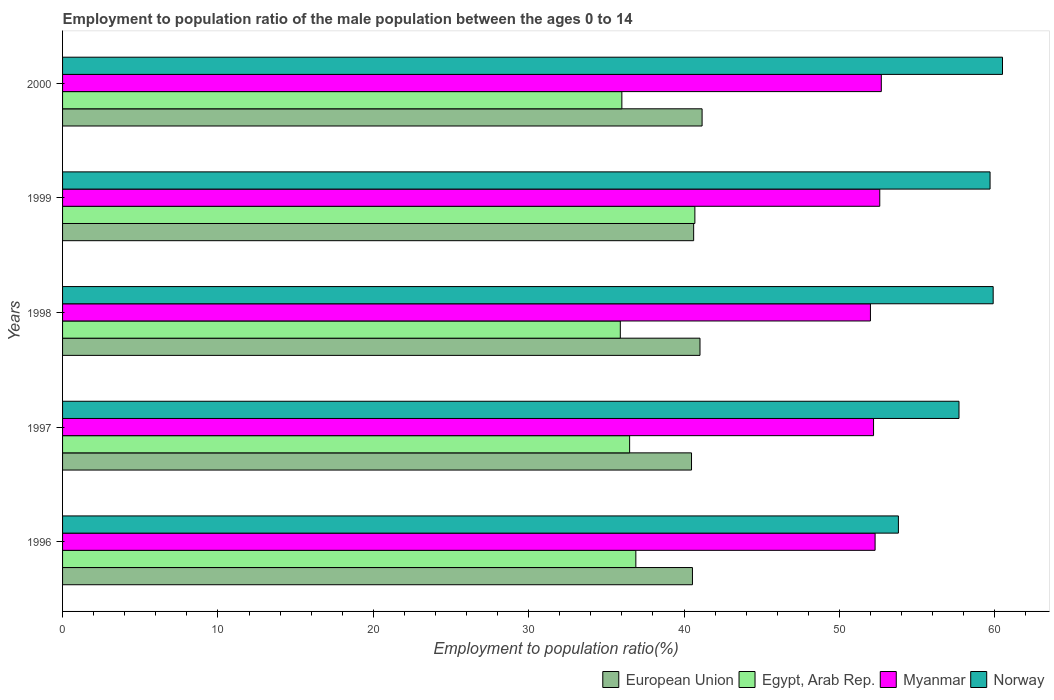How many different coloured bars are there?
Your answer should be compact. 4. Are the number of bars per tick equal to the number of legend labels?
Give a very brief answer. Yes. Are the number of bars on each tick of the Y-axis equal?
Keep it short and to the point. Yes. How many bars are there on the 4th tick from the top?
Ensure brevity in your answer.  4. What is the label of the 5th group of bars from the top?
Provide a succinct answer. 1996. What is the employment to population ratio in Norway in 1996?
Provide a succinct answer. 53.8. Across all years, what is the maximum employment to population ratio in Egypt, Arab Rep.?
Keep it short and to the point. 40.7. Across all years, what is the minimum employment to population ratio in Norway?
Your answer should be compact. 53.8. In which year was the employment to population ratio in European Union minimum?
Provide a succinct answer. 1997. What is the total employment to population ratio in European Union in the graph?
Your answer should be compact. 203.84. What is the difference between the employment to population ratio in European Union in 1996 and that in 1998?
Offer a very short reply. -0.49. What is the difference between the employment to population ratio in Egypt, Arab Rep. in 2000 and the employment to population ratio in Myanmar in 1998?
Your response must be concise. -16. What is the average employment to population ratio in European Union per year?
Offer a very short reply. 40.77. In the year 1997, what is the difference between the employment to population ratio in European Union and employment to population ratio in Norway?
Make the answer very short. -17.22. In how many years, is the employment to population ratio in Egypt, Arab Rep. greater than 30 %?
Give a very brief answer. 5. What is the ratio of the employment to population ratio in Egypt, Arab Rep. in 1996 to that in 2000?
Your answer should be compact. 1.03. What is the difference between the highest and the second highest employment to population ratio in European Union?
Keep it short and to the point. 0.13. What is the difference between the highest and the lowest employment to population ratio in Norway?
Your answer should be very brief. 6.7. In how many years, is the employment to population ratio in Myanmar greater than the average employment to population ratio in Myanmar taken over all years?
Your answer should be very brief. 2. Is the sum of the employment to population ratio in European Union in 1996 and 1997 greater than the maximum employment to population ratio in Myanmar across all years?
Your answer should be very brief. Yes. Is it the case that in every year, the sum of the employment to population ratio in Myanmar and employment to population ratio in Norway is greater than the employment to population ratio in Egypt, Arab Rep.?
Your answer should be compact. Yes. How many bars are there?
Make the answer very short. 20. Does the graph contain grids?
Ensure brevity in your answer.  No. Where does the legend appear in the graph?
Keep it short and to the point. Bottom right. How many legend labels are there?
Your answer should be very brief. 4. How are the legend labels stacked?
Provide a succinct answer. Horizontal. What is the title of the graph?
Your response must be concise. Employment to population ratio of the male population between the ages 0 to 14. What is the label or title of the Y-axis?
Keep it short and to the point. Years. What is the Employment to population ratio(%) of European Union in 1996?
Give a very brief answer. 40.54. What is the Employment to population ratio(%) of Egypt, Arab Rep. in 1996?
Ensure brevity in your answer.  36.9. What is the Employment to population ratio(%) of Myanmar in 1996?
Ensure brevity in your answer.  52.3. What is the Employment to population ratio(%) of Norway in 1996?
Your answer should be compact. 53.8. What is the Employment to population ratio(%) in European Union in 1997?
Your answer should be very brief. 40.48. What is the Employment to population ratio(%) in Egypt, Arab Rep. in 1997?
Offer a very short reply. 36.5. What is the Employment to population ratio(%) in Myanmar in 1997?
Your response must be concise. 52.2. What is the Employment to population ratio(%) of Norway in 1997?
Ensure brevity in your answer.  57.7. What is the Employment to population ratio(%) in European Union in 1998?
Your answer should be very brief. 41.03. What is the Employment to population ratio(%) in Egypt, Arab Rep. in 1998?
Ensure brevity in your answer.  35.9. What is the Employment to population ratio(%) of Myanmar in 1998?
Offer a terse response. 52. What is the Employment to population ratio(%) in Norway in 1998?
Your response must be concise. 59.9. What is the Employment to population ratio(%) of European Union in 1999?
Your response must be concise. 40.62. What is the Employment to population ratio(%) of Egypt, Arab Rep. in 1999?
Provide a short and direct response. 40.7. What is the Employment to population ratio(%) of Myanmar in 1999?
Provide a succinct answer. 52.6. What is the Employment to population ratio(%) of Norway in 1999?
Offer a very short reply. 59.7. What is the Employment to population ratio(%) of European Union in 2000?
Make the answer very short. 41.16. What is the Employment to population ratio(%) of Myanmar in 2000?
Make the answer very short. 52.7. What is the Employment to population ratio(%) in Norway in 2000?
Make the answer very short. 60.5. Across all years, what is the maximum Employment to population ratio(%) in European Union?
Make the answer very short. 41.16. Across all years, what is the maximum Employment to population ratio(%) in Egypt, Arab Rep.?
Provide a succinct answer. 40.7. Across all years, what is the maximum Employment to population ratio(%) in Myanmar?
Your response must be concise. 52.7. Across all years, what is the maximum Employment to population ratio(%) in Norway?
Ensure brevity in your answer.  60.5. Across all years, what is the minimum Employment to population ratio(%) of European Union?
Ensure brevity in your answer.  40.48. Across all years, what is the minimum Employment to population ratio(%) of Egypt, Arab Rep.?
Give a very brief answer. 35.9. Across all years, what is the minimum Employment to population ratio(%) in Norway?
Ensure brevity in your answer.  53.8. What is the total Employment to population ratio(%) of European Union in the graph?
Ensure brevity in your answer.  203.84. What is the total Employment to population ratio(%) in Egypt, Arab Rep. in the graph?
Make the answer very short. 186. What is the total Employment to population ratio(%) of Myanmar in the graph?
Ensure brevity in your answer.  261.8. What is the total Employment to population ratio(%) of Norway in the graph?
Your answer should be very brief. 291.6. What is the difference between the Employment to population ratio(%) of European Union in 1996 and that in 1997?
Keep it short and to the point. 0.06. What is the difference between the Employment to population ratio(%) in Myanmar in 1996 and that in 1997?
Offer a terse response. 0.1. What is the difference between the Employment to population ratio(%) in Norway in 1996 and that in 1997?
Offer a terse response. -3.9. What is the difference between the Employment to population ratio(%) in European Union in 1996 and that in 1998?
Give a very brief answer. -0.49. What is the difference between the Employment to population ratio(%) of Myanmar in 1996 and that in 1998?
Offer a terse response. 0.3. What is the difference between the Employment to population ratio(%) of European Union in 1996 and that in 1999?
Provide a short and direct response. -0.08. What is the difference between the Employment to population ratio(%) of Egypt, Arab Rep. in 1996 and that in 1999?
Ensure brevity in your answer.  -3.8. What is the difference between the Employment to population ratio(%) in Norway in 1996 and that in 1999?
Offer a very short reply. -5.9. What is the difference between the Employment to population ratio(%) of European Union in 1996 and that in 2000?
Ensure brevity in your answer.  -0.62. What is the difference between the Employment to population ratio(%) in Norway in 1996 and that in 2000?
Ensure brevity in your answer.  -6.7. What is the difference between the Employment to population ratio(%) in European Union in 1997 and that in 1998?
Ensure brevity in your answer.  -0.55. What is the difference between the Employment to population ratio(%) of European Union in 1997 and that in 1999?
Provide a short and direct response. -0.14. What is the difference between the Employment to population ratio(%) of Egypt, Arab Rep. in 1997 and that in 1999?
Keep it short and to the point. -4.2. What is the difference between the Employment to population ratio(%) in Myanmar in 1997 and that in 1999?
Offer a terse response. -0.4. What is the difference between the Employment to population ratio(%) of Norway in 1997 and that in 1999?
Provide a short and direct response. -2. What is the difference between the Employment to population ratio(%) of European Union in 1997 and that in 2000?
Offer a very short reply. -0.68. What is the difference between the Employment to population ratio(%) of Egypt, Arab Rep. in 1997 and that in 2000?
Provide a succinct answer. 0.5. What is the difference between the Employment to population ratio(%) of Myanmar in 1997 and that in 2000?
Keep it short and to the point. -0.5. What is the difference between the Employment to population ratio(%) of European Union in 1998 and that in 1999?
Your response must be concise. 0.41. What is the difference between the Employment to population ratio(%) in Myanmar in 1998 and that in 1999?
Offer a terse response. -0.6. What is the difference between the Employment to population ratio(%) in Norway in 1998 and that in 1999?
Offer a very short reply. 0.2. What is the difference between the Employment to population ratio(%) in European Union in 1998 and that in 2000?
Make the answer very short. -0.13. What is the difference between the Employment to population ratio(%) of Egypt, Arab Rep. in 1998 and that in 2000?
Ensure brevity in your answer.  -0.1. What is the difference between the Employment to population ratio(%) in European Union in 1999 and that in 2000?
Provide a short and direct response. -0.54. What is the difference between the Employment to population ratio(%) in European Union in 1996 and the Employment to population ratio(%) in Egypt, Arab Rep. in 1997?
Provide a short and direct response. 4.04. What is the difference between the Employment to population ratio(%) in European Union in 1996 and the Employment to population ratio(%) in Myanmar in 1997?
Provide a succinct answer. -11.66. What is the difference between the Employment to population ratio(%) in European Union in 1996 and the Employment to population ratio(%) in Norway in 1997?
Your response must be concise. -17.16. What is the difference between the Employment to population ratio(%) in Egypt, Arab Rep. in 1996 and the Employment to population ratio(%) in Myanmar in 1997?
Your answer should be compact. -15.3. What is the difference between the Employment to population ratio(%) in Egypt, Arab Rep. in 1996 and the Employment to population ratio(%) in Norway in 1997?
Offer a very short reply. -20.8. What is the difference between the Employment to population ratio(%) in European Union in 1996 and the Employment to population ratio(%) in Egypt, Arab Rep. in 1998?
Your answer should be very brief. 4.64. What is the difference between the Employment to population ratio(%) in European Union in 1996 and the Employment to population ratio(%) in Myanmar in 1998?
Keep it short and to the point. -11.46. What is the difference between the Employment to population ratio(%) in European Union in 1996 and the Employment to population ratio(%) in Norway in 1998?
Keep it short and to the point. -19.36. What is the difference between the Employment to population ratio(%) in Egypt, Arab Rep. in 1996 and the Employment to population ratio(%) in Myanmar in 1998?
Offer a terse response. -15.1. What is the difference between the Employment to population ratio(%) of Egypt, Arab Rep. in 1996 and the Employment to population ratio(%) of Norway in 1998?
Your answer should be very brief. -23. What is the difference between the Employment to population ratio(%) in European Union in 1996 and the Employment to population ratio(%) in Egypt, Arab Rep. in 1999?
Offer a very short reply. -0.16. What is the difference between the Employment to population ratio(%) in European Union in 1996 and the Employment to population ratio(%) in Myanmar in 1999?
Ensure brevity in your answer.  -12.06. What is the difference between the Employment to population ratio(%) of European Union in 1996 and the Employment to population ratio(%) of Norway in 1999?
Your response must be concise. -19.16. What is the difference between the Employment to population ratio(%) of Egypt, Arab Rep. in 1996 and the Employment to population ratio(%) of Myanmar in 1999?
Make the answer very short. -15.7. What is the difference between the Employment to population ratio(%) in Egypt, Arab Rep. in 1996 and the Employment to population ratio(%) in Norway in 1999?
Make the answer very short. -22.8. What is the difference between the Employment to population ratio(%) of European Union in 1996 and the Employment to population ratio(%) of Egypt, Arab Rep. in 2000?
Offer a very short reply. 4.54. What is the difference between the Employment to population ratio(%) in European Union in 1996 and the Employment to population ratio(%) in Myanmar in 2000?
Make the answer very short. -12.16. What is the difference between the Employment to population ratio(%) of European Union in 1996 and the Employment to population ratio(%) of Norway in 2000?
Provide a short and direct response. -19.96. What is the difference between the Employment to population ratio(%) in Egypt, Arab Rep. in 1996 and the Employment to population ratio(%) in Myanmar in 2000?
Make the answer very short. -15.8. What is the difference between the Employment to population ratio(%) of Egypt, Arab Rep. in 1996 and the Employment to population ratio(%) of Norway in 2000?
Provide a succinct answer. -23.6. What is the difference between the Employment to population ratio(%) of European Union in 1997 and the Employment to population ratio(%) of Egypt, Arab Rep. in 1998?
Your answer should be compact. 4.58. What is the difference between the Employment to population ratio(%) in European Union in 1997 and the Employment to population ratio(%) in Myanmar in 1998?
Provide a short and direct response. -11.52. What is the difference between the Employment to population ratio(%) of European Union in 1997 and the Employment to population ratio(%) of Norway in 1998?
Provide a succinct answer. -19.42. What is the difference between the Employment to population ratio(%) in Egypt, Arab Rep. in 1997 and the Employment to population ratio(%) in Myanmar in 1998?
Keep it short and to the point. -15.5. What is the difference between the Employment to population ratio(%) in Egypt, Arab Rep. in 1997 and the Employment to population ratio(%) in Norway in 1998?
Make the answer very short. -23.4. What is the difference between the Employment to population ratio(%) of European Union in 1997 and the Employment to population ratio(%) of Egypt, Arab Rep. in 1999?
Offer a terse response. -0.22. What is the difference between the Employment to population ratio(%) in European Union in 1997 and the Employment to population ratio(%) in Myanmar in 1999?
Ensure brevity in your answer.  -12.12. What is the difference between the Employment to population ratio(%) of European Union in 1997 and the Employment to population ratio(%) of Norway in 1999?
Your answer should be compact. -19.22. What is the difference between the Employment to population ratio(%) of Egypt, Arab Rep. in 1997 and the Employment to population ratio(%) of Myanmar in 1999?
Make the answer very short. -16.1. What is the difference between the Employment to population ratio(%) in Egypt, Arab Rep. in 1997 and the Employment to population ratio(%) in Norway in 1999?
Provide a short and direct response. -23.2. What is the difference between the Employment to population ratio(%) of Myanmar in 1997 and the Employment to population ratio(%) of Norway in 1999?
Offer a very short reply. -7.5. What is the difference between the Employment to population ratio(%) of European Union in 1997 and the Employment to population ratio(%) of Egypt, Arab Rep. in 2000?
Your answer should be compact. 4.48. What is the difference between the Employment to population ratio(%) in European Union in 1997 and the Employment to population ratio(%) in Myanmar in 2000?
Your answer should be very brief. -12.22. What is the difference between the Employment to population ratio(%) of European Union in 1997 and the Employment to population ratio(%) of Norway in 2000?
Provide a short and direct response. -20.02. What is the difference between the Employment to population ratio(%) in Egypt, Arab Rep. in 1997 and the Employment to population ratio(%) in Myanmar in 2000?
Provide a short and direct response. -16.2. What is the difference between the Employment to population ratio(%) of European Union in 1998 and the Employment to population ratio(%) of Egypt, Arab Rep. in 1999?
Provide a short and direct response. 0.33. What is the difference between the Employment to population ratio(%) in European Union in 1998 and the Employment to population ratio(%) in Myanmar in 1999?
Your answer should be very brief. -11.57. What is the difference between the Employment to population ratio(%) of European Union in 1998 and the Employment to population ratio(%) of Norway in 1999?
Provide a short and direct response. -18.67. What is the difference between the Employment to population ratio(%) in Egypt, Arab Rep. in 1998 and the Employment to population ratio(%) in Myanmar in 1999?
Your response must be concise. -16.7. What is the difference between the Employment to population ratio(%) in Egypt, Arab Rep. in 1998 and the Employment to population ratio(%) in Norway in 1999?
Offer a very short reply. -23.8. What is the difference between the Employment to population ratio(%) of European Union in 1998 and the Employment to population ratio(%) of Egypt, Arab Rep. in 2000?
Your response must be concise. 5.03. What is the difference between the Employment to population ratio(%) in European Union in 1998 and the Employment to population ratio(%) in Myanmar in 2000?
Provide a short and direct response. -11.67. What is the difference between the Employment to population ratio(%) in European Union in 1998 and the Employment to population ratio(%) in Norway in 2000?
Make the answer very short. -19.47. What is the difference between the Employment to population ratio(%) of Egypt, Arab Rep. in 1998 and the Employment to population ratio(%) of Myanmar in 2000?
Ensure brevity in your answer.  -16.8. What is the difference between the Employment to population ratio(%) of Egypt, Arab Rep. in 1998 and the Employment to population ratio(%) of Norway in 2000?
Ensure brevity in your answer.  -24.6. What is the difference between the Employment to population ratio(%) of European Union in 1999 and the Employment to population ratio(%) of Egypt, Arab Rep. in 2000?
Provide a succinct answer. 4.62. What is the difference between the Employment to population ratio(%) of European Union in 1999 and the Employment to population ratio(%) of Myanmar in 2000?
Your response must be concise. -12.08. What is the difference between the Employment to population ratio(%) of European Union in 1999 and the Employment to population ratio(%) of Norway in 2000?
Offer a very short reply. -19.88. What is the difference between the Employment to population ratio(%) in Egypt, Arab Rep. in 1999 and the Employment to population ratio(%) in Myanmar in 2000?
Your answer should be compact. -12. What is the difference between the Employment to population ratio(%) of Egypt, Arab Rep. in 1999 and the Employment to population ratio(%) of Norway in 2000?
Keep it short and to the point. -19.8. What is the difference between the Employment to population ratio(%) in Myanmar in 1999 and the Employment to population ratio(%) in Norway in 2000?
Your answer should be very brief. -7.9. What is the average Employment to population ratio(%) in European Union per year?
Offer a very short reply. 40.77. What is the average Employment to population ratio(%) of Egypt, Arab Rep. per year?
Your response must be concise. 37.2. What is the average Employment to population ratio(%) in Myanmar per year?
Give a very brief answer. 52.36. What is the average Employment to population ratio(%) of Norway per year?
Offer a very short reply. 58.32. In the year 1996, what is the difference between the Employment to population ratio(%) of European Union and Employment to population ratio(%) of Egypt, Arab Rep.?
Make the answer very short. 3.64. In the year 1996, what is the difference between the Employment to population ratio(%) in European Union and Employment to population ratio(%) in Myanmar?
Keep it short and to the point. -11.76. In the year 1996, what is the difference between the Employment to population ratio(%) in European Union and Employment to population ratio(%) in Norway?
Provide a short and direct response. -13.26. In the year 1996, what is the difference between the Employment to population ratio(%) in Egypt, Arab Rep. and Employment to population ratio(%) in Myanmar?
Offer a terse response. -15.4. In the year 1996, what is the difference between the Employment to population ratio(%) in Egypt, Arab Rep. and Employment to population ratio(%) in Norway?
Provide a succinct answer. -16.9. In the year 1997, what is the difference between the Employment to population ratio(%) of European Union and Employment to population ratio(%) of Egypt, Arab Rep.?
Provide a succinct answer. 3.98. In the year 1997, what is the difference between the Employment to population ratio(%) of European Union and Employment to population ratio(%) of Myanmar?
Your answer should be very brief. -11.72. In the year 1997, what is the difference between the Employment to population ratio(%) in European Union and Employment to population ratio(%) in Norway?
Keep it short and to the point. -17.22. In the year 1997, what is the difference between the Employment to population ratio(%) of Egypt, Arab Rep. and Employment to population ratio(%) of Myanmar?
Keep it short and to the point. -15.7. In the year 1997, what is the difference between the Employment to population ratio(%) in Egypt, Arab Rep. and Employment to population ratio(%) in Norway?
Offer a very short reply. -21.2. In the year 1997, what is the difference between the Employment to population ratio(%) of Myanmar and Employment to population ratio(%) of Norway?
Your answer should be very brief. -5.5. In the year 1998, what is the difference between the Employment to population ratio(%) of European Union and Employment to population ratio(%) of Egypt, Arab Rep.?
Provide a succinct answer. 5.13. In the year 1998, what is the difference between the Employment to population ratio(%) of European Union and Employment to population ratio(%) of Myanmar?
Provide a short and direct response. -10.97. In the year 1998, what is the difference between the Employment to population ratio(%) in European Union and Employment to population ratio(%) in Norway?
Your answer should be very brief. -18.87. In the year 1998, what is the difference between the Employment to population ratio(%) of Egypt, Arab Rep. and Employment to population ratio(%) of Myanmar?
Keep it short and to the point. -16.1. In the year 1998, what is the difference between the Employment to population ratio(%) of Egypt, Arab Rep. and Employment to population ratio(%) of Norway?
Provide a succinct answer. -24. In the year 1998, what is the difference between the Employment to population ratio(%) of Myanmar and Employment to population ratio(%) of Norway?
Your response must be concise. -7.9. In the year 1999, what is the difference between the Employment to population ratio(%) in European Union and Employment to population ratio(%) in Egypt, Arab Rep.?
Provide a succinct answer. -0.08. In the year 1999, what is the difference between the Employment to population ratio(%) in European Union and Employment to population ratio(%) in Myanmar?
Your response must be concise. -11.98. In the year 1999, what is the difference between the Employment to population ratio(%) in European Union and Employment to population ratio(%) in Norway?
Provide a short and direct response. -19.08. In the year 1999, what is the difference between the Employment to population ratio(%) of Egypt, Arab Rep. and Employment to population ratio(%) of Myanmar?
Make the answer very short. -11.9. In the year 1999, what is the difference between the Employment to population ratio(%) in Myanmar and Employment to population ratio(%) in Norway?
Provide a succinct answer. -7.1. In the year 2000, what is the difference between the Employment to population ratio(%) of European Union and Employment to population ratio(%) of Egypt, Arab Rep.?
Provide a succinct answer. 5.16. In the year 2000, what is the difference between the Employment to population ratio(%) in European Union and Employment to population ratio(%) in Myanmar?
Make the answer very short. -11.54. In the year 2000, what is the difference between the Employment to population ratio(%) of European Union and Employment to population ratio(%) of Norway?
Provide a short and direct response. -19.34. In the year 2000, what is the difference between the Employment to population ratio(%) of Egypt, Arab Rep. and Employment to population ratio(%) of Myanmar?
Your response must be concise. -16.7. In the year 2000, what is the difference between the Employment to population ratio(%) in Egypt, Arab Rep. and Employment to population ratio(%) in Norway?
Your answer should be compact. -24.5. In the year 2000, what is the difference between the Employment to population ratio(%) of Myanmar and Employment to population ratio(%) of Norway?
Your response must be concise. -7.8. What is the ratio of the Employment to population ratio(%) of Norway in 1996 to that in 1997?
Give a very brief answer. 0.93. What is the ratio of the Employment to population ratio(%) in Egypt, Arab Rep. in 1996 to that in 1998?
Make the answer very short. 1.03. What is the ratio of the Employment to population ratio(%) of Myanmar in 1996 to that in 1998?
Provide a short and direct response. 1.01. What is the ratio of the Employment to population ratio(%) of Norway in 1996 to that in 1998?
Your answer should be very brief. 0.9. What is the ratio of the Employment to population ratio(%) of European Union in 1996 to that in 1999?
Offer a very short reply. 1. What is the ratio of the Employment to population ratio(%) of Egypt, Arab Rep. in 1996 to that in 1999?
Provide a short and direct response. 0.91. What is the ratio of the Employment to population ratio(%) of Norway in 1996 to that in 1999?
Keep it short and to the point. 0.9. What is the ratio of the Employment to population ratio(%) in European Union in 1996 to that in 2000?
Your answer should be very brief. 0.98. What is the ratio of the Employment to population ratio(%) in Myanmar in 1996 to that in 2000?
Provide a short and direct response. 0.99. What is the ratio of the Employment to population ratio(%) in Norway in 1996 to that in 2000?
Provide a succinct answer. 0.89. What is the ratio of the Employment to population ratio(%) of European Union in 1997 to that in 1998?
Provide a succinct answer. 0.99. What is the ratio of the Employment to population ratio(%) in Egypt, Arab Rep. in 1997 to that in 1998?
Your answer should be very brief. 1.02. What is the ratio of the Employment to population ratio(%) of Myanmar in 1997 to that in 1998?
Provide a succinct answer. 1. What is the ratio of the Employment to population ratio(%) of Norway in 1997 to that in 1998?
Your answer should be compact. 0.96. What is the ratio of the Employment to population ratio(%) in European Union in 1997 to that in 1999?
Offer a terse response. 1. What is the ratio of the Employment to population ratio(%) in Egypt, Arab Rep. in 1997 to that in 1999?
Your answer should be compact. 0.9. What is the ratio of the Employment to population ratio(%) of Myanmar in 1997 to that in 1999?
Give a very brief answer. 0.99. What is the ratio of the Employment to population ratio(%) of Norway in 1997 to that in 1999?
Offer a very short reply. 0.97. What is the ratio of the Employment to population ratio(%) of European Union in 1997 to that in 2000?
Offer a terse response. 0.98. What is the ratio of the Employment to population ratio(%) in Egypt, Arab Rep. in 1997 to that in 2000?
Keep it short and to the point. 1.01. What is the ratio of the Employment to population ratio(%) of Norway in 1997 to that in 2000?
Offer a terse response. 0.95. What is the ratio of the Employment to population ratio(%) of European Union in 1998 to that in 1999?
Your answer should be compact. 1.01. What is the ratio of the Employment to population ratio(%) in Egypt, Arab Rep. in 1998 to that in 1999?
Make the answer very short. 0.88. What is the ratio of the Employment to population ratio(%) of European Union in 1998 to that in 2000?
Your answer should be very brief. 1. What is the ratio of the Employment to population ratio(%) in Myanmar in 1998 to that in 2000?
Your answer should be compact. 0.99. What is the ratio of the Employment to population ratio(%) in European Union in 1999 to that in 2000?
Offer a terse response. 0.99. What is the ratio of the Employment to population ratio(%) in Egypt, Arab Rep. in 1999 to that in 2000?
Provide a short and direct response. 1.13. What is the difference between the highest and the second highest Employment to population ratio(%) of European Union?
Offer a very short reply. 0.13. What is the difference between the highest and the second highest Employment to population ratio(%) in Egypt, Arab Rep.?
Give a very brief answer. 3.8. What is the difference between the highest and the second highest Employment to population ratio(%) of Myanmar?
Provide a succinct answer. 0.1. What is the difference between the highest and the lowest Employment to population ratio(%) of European Union?
Give a very brief answer. 0.68. What is the difference between the highest and the lowest Employment to population ratio(%) in Egypt, Arab Rep.?
Ensure brevity in your answer.  4.8. What is the difference between the highest and the lowest Employment to population ratio(%) in Myanmar?
Offer a terse response. 0.7. What is the difference between the highest and the lowest Employment to population ratio(%) in Norway?
Give a very brief answer. 6.7. 